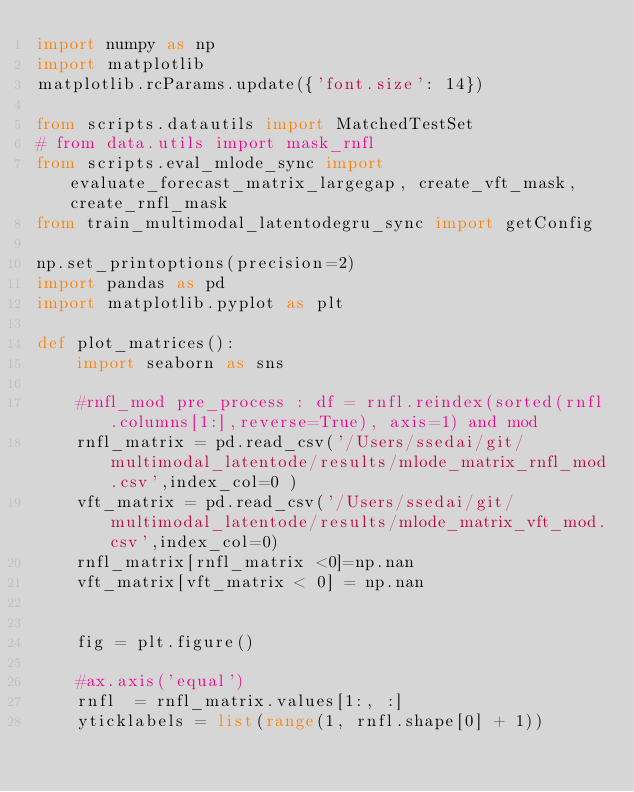Convert code to text. <code><loc_0><loc_0><loc_500><loc_500><_Python_>import numpy as np
import matplotlib
matplotlib.rcParams.update({'font.size': 14})

from scripts.datautils import MatchedTestSet
# from data.utils import mask_rnfl
from scripts.eval_mlode_sync import evaluate_forecast_matrix_largegap, create_vft_mask, create_rnfl_mask
from train_multimodal_latentodegru_sync import getConfig

np.set_printoptions(precision=2)
import pandas as pd
import matplotlib.pyplot as plt

def plot_matrices():
    import seaborn as sns

    #rnfl_mod pre_process : df = rnfl.reindex(sorted(rnfl.columns[1:],reverse=True), axis=1) and mod
    rnfl_matrix = pd.read_csv('/Users/ssedai/git/multimodal_latentode/results/mlode_matrix_rnfl_mod.csv',index_col=0 )
    vft_matrix = pd.read_csv('/Users/ssedai/git/multimodal_latentode/results/mlode_matrix_vft_mod.csv',index_col=0)
    rnfl_matrix[rnfl_matrix <0]=np.nan
    vft_matrix[vft_matrix < 0] = np.nan


    fig = plt.figure()

    #ax.axis('equal')
    rnfl  = rnfl_matrix.values[1:, :]
    yticklabels = list(range(1, rnfl.shape[0] + 1))</code> 